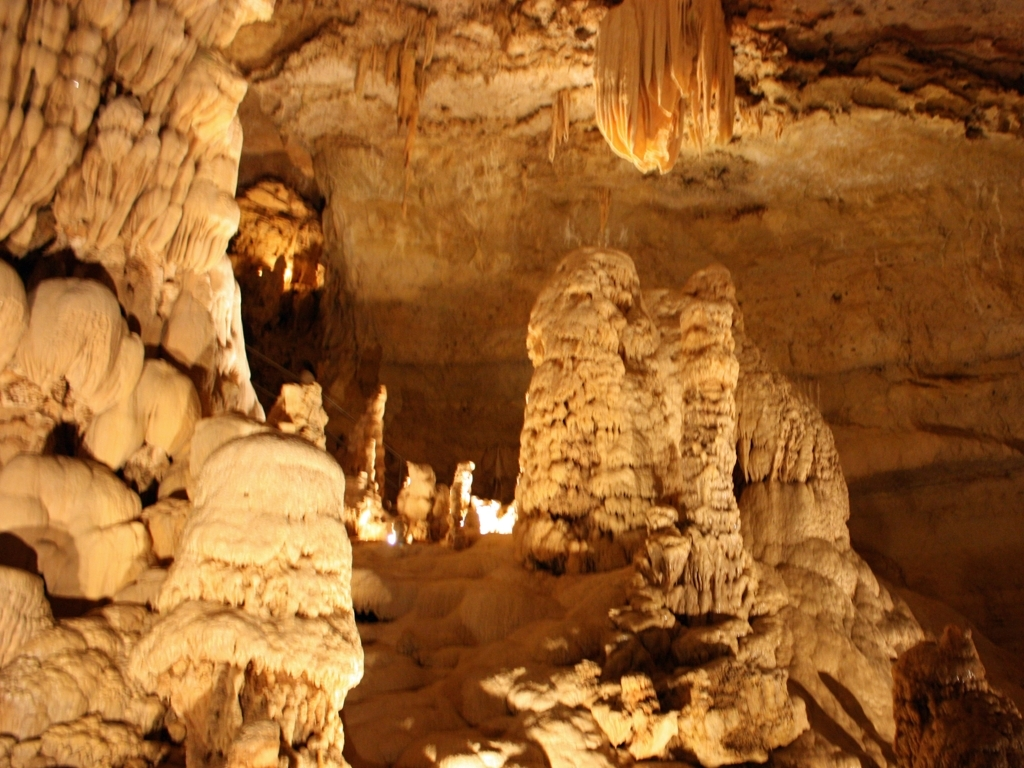What sort of experience might a visitor have in this cave? Visitors to this cave would likely experience a sense of awe at the natural beauty and grandeur of the formations. The play of light and shadow can create an otherworldly ambiance, offering a serene and contemplative environment. Textures and shapes around each corner would provide a unique visual treat, enriching the visitor's understanding and appreciation of geological processes. 